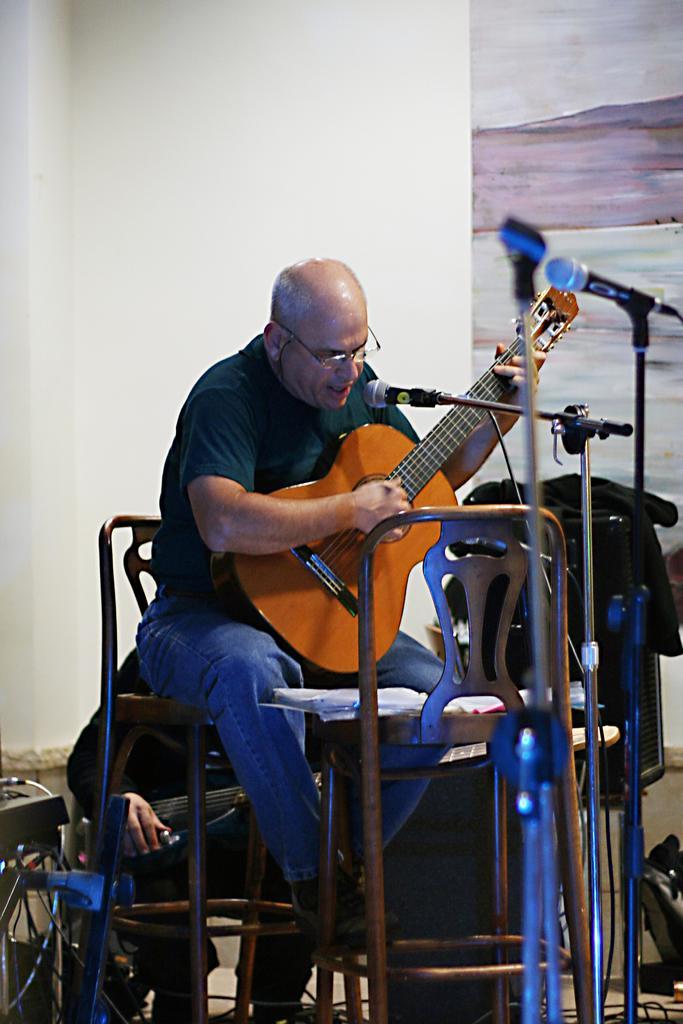Can you describe this image briefly? In this picture we can see a man sitting on a chair in front of a mike, singing and playing. He wore spectacles. Behind to him we can see other person. On the background there is a wall. 